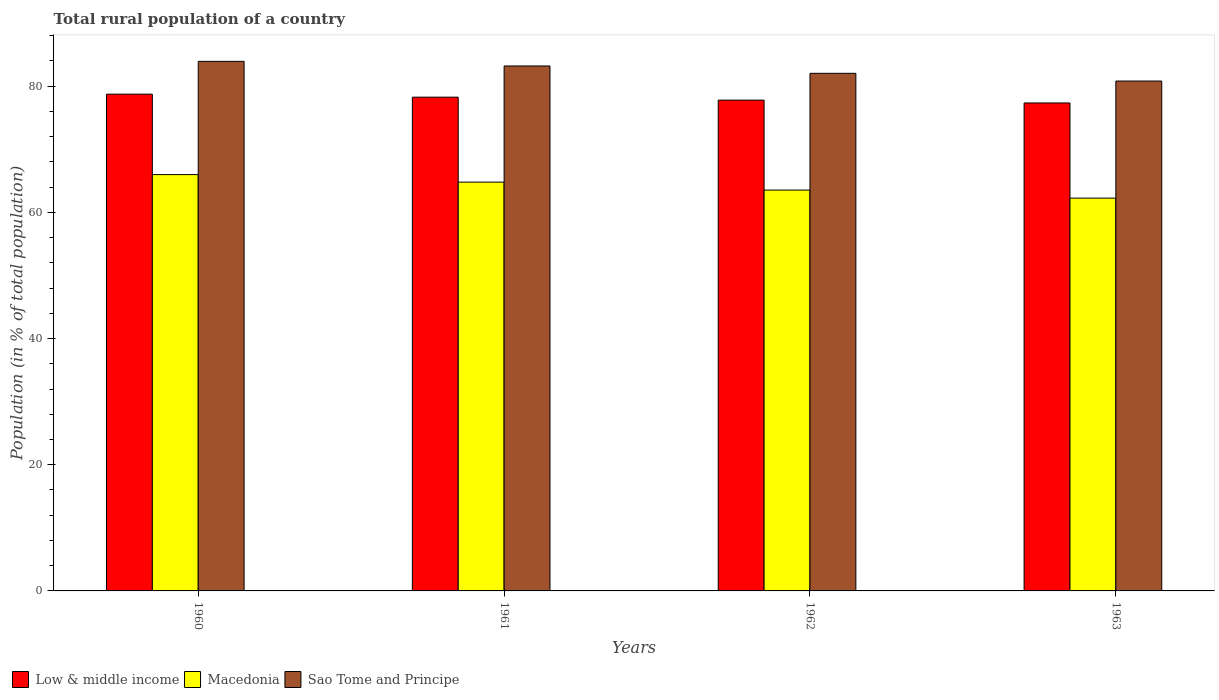How many bars are there on the 4th tick from the right?
Ensure brevity in your answer.  3. What is the label of the 1st group of bars from the left?
Keep it short and to the point. 1960. In how many cases, is the number of bars for a given year not equal to the number of legend labels?
Give a very brief answer. 0. What is the rural population in Low & middle income in 1960?
Your answer should be compact. 78.73. Across all years, what is the maximum rural population in Low & middle income?
Keep it short and to the point. 78.73. Across all years, what is the minimum rural population in Low & middle income?
Offer a very short reply. 77.33. In which year was the rural population in Macedonia minimum?
Your response must be concise. 1963. What is the total rural population in Macedonia in the graph?
Ensure brevity in your answer.  256.54. What is the difference between the rural population in Sao Tome and Principe in 1961 and that in 1963?
Offer a terse response. 2.39. What is the difference between the rural population in Macedonia in 1962 and the rural population in Sao Tome and Principe in 1960?
Your response must be concise. -20.4. What is the average rural population in Macedonia per year?
Keep it short and to the point. 64.14. In the year 1961, what is the difference between the rural population in Sao Tome and Principe and rural population in Low & middle income?
Your answer should be compact. 4.94. In how many years, is the rural population in Low & middle income greater than 52 %?
Your answer should be very brief. 4. What is the ratio of the rural population in Low & middle income in 1960 to that in 1961?
Offer a very short reply. 1.01. Is the rural population in Low & middle income in 1962 less than that in 1963?
Provide a succinct answer. No. What is the difference between the highest and the second highest rural population in Low & middle income?
Your answer should be very brief. 0.48. What is the difference between the highest and the lowest rural population in Macedonia?
Give a very brief answer. 3.73. Is the sum of the rural population in Low & middle income in 1960 and 1961 greater than the maximum rural population in Sao Tome and Principe across all years?
Make the answer very short. Yes. What does the 3rd bar from the left in 1961 represents?
Keep it short and to the point. Sao Tome and Principe. What does the 2nd bar from the right in 1960 represents?
Make the answer very short. Macedonia. How many bars are there?
Give a very brief answer. 12. Are all the bars in the graph horizontal?
Ensure brevity in your answer.  No. How many years are there in the graph?
Provide a succinct answer. 4. Are the values on the major ticks of Y-axis written in scientific E-notation?
Ensure brevity in your answer.  No. Does the graph contain any zero values?
Provide a short and direct response. No. Does the graph contain grids?
Keep it short and to the point. No. Where does the legend appear in the graph?
Your response must be concise. Bottom left. How many legend labels are there?
Your answer should be very brief. 3. What is the title of the graph?
Offer a very short reply. Total rural population of a country. What is the label or title of the X-axis?
Your answer should be compact. Years. What is the label or title of the Y-axis?
Give a very brief answer. Population (in % of total population). What is the Population (in % of total population) in Low & middle income in 1960?
Offer a very short reply. 78.73. What is the Population (in % of total population) in Macedonia in 1960?
Your answer should be very brief. 65.98. What is the Population (in % of total population) of Sao Tome and Principe in 1960?
Offer a very short reply. 83.93. What is the Population (in % of total population) of Low & middle income in 1961?
Make the answer very short. 78.25. What is the Population (in % of total population) in Macedonia in 1961?
Keep it short and to the point. 64.79. What is the Population (in % of total population) of Sao Tome and Principe in 1961?
Your response must be concise. 83.19. What is the Population (in % of total population) of Low & middle income in 1962?
Offer a very short reply. 77.78. What is the Population (in % of total population) of Macedonia in 1962?
Keep it short and to the point. 63.53. What is the Population (in % of total population) of Sao Tome and Principe in 1962?
Keep it short and to the point. 82.03. What is the Population (in % of total population) of Low & middle income in 1963?
Your answer should be compact. 77.33. What is the Population (in % of total population) in Macedonia in 1963?
Your answer should be compact. 62.25. What is the Population (in % of total population) in Sao Tome and Principe in 1963?
Offer a very short reply. 80.81. Across all years, what is the maximum Population (in % of total population) of Low & middle income?
Your answer should be very brief. 78.73. Across all years, what is the maximum Population (in % of total population) in Macedonia?
Your response must be concise. 65.98. Across all years, what is the maximum Population (in % of total population) of Sao Tome and Principe?
Ensure brevity in your answer.  83.93. Across all years, what is the minimum Population (in % of total population) in Low & middle income?
Your response must be concise. 77.33. Across all years, what is the minimum Population (in % of total population) in Macedonia?
Your answer should be compact. 62.25. Across all years, what is the minimum Population (in % of total population) of Sao Tome and Principe?
Offer a very short reply. 80.81. What is the total Population (in % of total population) in Low & middle income in the graph?
Your answer should be compact. 312.09. What is the total Population (in % of total population) in Macedonia in the graph?
Make the answer very short. 256.54. What is the total Population (in % of total population) in Sao Tome and Principe in the graph?
Give a very brief answer. 329.96. What is the difference between the Population (in % of total population) in Low & middle income in 1960 and that in 1961?
Your answer should be compact. 0.48. What is the difference between the Population (in % of total population) in Macedonia in 1960 and that in 1961?
Your answer should be very brief. 1.19. What is the difference between the Population (in % of total population) in Sao Tome and Principe in 1960 and that in 1961?
Keep it short and to the point. 0.73. What is the difference between the Population (in % of total population) in Low & middle income in 1960 and that in 1962?
Your answer should be compact. 0.95. What is the difference between the Population (in % of total population) of Macedonia in 1960 and that in 1962?
Your answer should be compact. 2.45. What is the difference between the Population (in % of total population) in Sao Tome and Principe in 1960 and that in 1962?
Keep it short and to the point. 1.9. What is the difference between the Population (in % of total population) in Low & middle income in 1960 and that in 1963?
Offer a terse response. 1.39. What is the difference between the Population (in % of total population) in Macedonia in 1960 and that in 1963?
Provide a short and direct response. 3.73. What is the difference between the Population (in % of total population) of Sao Tome and Principe in 1960 and that in 1963?
Offer a very short reply. 3.12. What is the difference between the Population (in % of total population) of Low & middle income in 1961 and that in 1962?
Provide a succinct answer. 0.47. What is the difference between the Population (in % of total population) in Macedonia in 1961 and that in 1962?
Your response must be concise. 1.26. What is the difference between the Population (in % of total population) of Sao Tome and Principe in 1961 and that in 1962?
Give a very brief answer. 1.16. What is the difference between the Population (in % of total population) of Low & middle income in 1961 and that in 1963?
Provide a succinct answer. 0.92. What is the difference between the Population (in % of total population) of Macedonia in 1961 and that in 1963?
Give a very brief answer. 2.54. What is the difference between the Population (in % of total population) of Sao Tome and Principe in 1961 and that in 1963?
Your answer should be compact. 2.39. What is the difference between the Population (in % of total population) in Low & middle income in 1962 and that in 1963?
Your answer should be compact. 0.45. What is the difference between the Population (in % of total population) of Macedonia in 1962 and that in 1963?
Your answer should be compact. 1.28. What is the difference between the Population (in % of total population) in Sao Tome and Principe in 1962 and that in 1963?
Ensure brevity in your answer.  1.23. What is the difference between the Population (in % of total population) in Low & middle income in 1960 and the Population (in % of total population) in Macedonia in 1961?
Ensure brevity in your answer.  13.94. What is the difference between the Population (in % of total population) in Low & middle income in 1960 and the Population (in % of total population) in Sao Tome and Principe in 1961?
Ensure brevity in your answer.  -4.47. What is the difference between the Population (in % of total population) of Macedonia in 1960 and the Population (in % of total population) of Sao Tome and Principe in 1961?
Your response must be concise. -17.21. What is the difference between the Population (in % of total population) of Low & middle income in 1960 and the Population (in % of total population) of Macedonia in 1962?
Your answer should be compact. 15.2. What is the difference between the Population (in % of total population) in Low & middle income in 1960 and the Population (in % of total population) in Sao Tome and Principe in 1962?
Your answer should be compact. -3.3. What is the difference between the Population (in % of total population) in Macedonia in 1960 and the Population (in % of total population) in Sao Tome and Principe in 1962?
Your answer should be compact. -16.05. What is the difference between the Population (in % of total population) of Low & middle income in 1960 and the Population (in % of total population) of Macedonia in 1963?
Your response must be concise. 16.48. What is the difference between the Population (in % of total population) in Low & middle income in 1960 and the Population (in % of total population) in Sao Tome and Principe in 1963?
Provide a succinct answer. -2.08. What is the difference between the Population (in % of total population) in Macedonia in 1960 and the Population (in % of total population) in Sao Tome and Principe in 1963?
Provide a succinct answer. -14.83. What is the difference between the Population (in % of total population) of Low & middle income in 1961 and the Population (in % of total population) of Macedonia in 1962?
Offer a very short reply. 14.72. What is the difference between the Population (in % of total population) in Low & middle income in 1961 and the Population (in % of total population) in Sao Tome and Principe in 1962?
Offer a terse response. -3.78. What is the difference between the Population (in % of total population) of Macedonia in 1961 and the Population (in % of total population) of Sao Tome and Principe in 1962?
Offer a very short reply. -17.25. What is the difference between the Population (in % of total population) of Low & middle income in 1961 and the Population (in % of total population) of Macedonia in 1963?
Provide a succinct answer. 16. What is the difference between the Population (in % of total population) in Low & middle income in 1961 and the Population (in % of total population) in Sao Tome and Principe in 1963?
Provide a succinct answer. -2.56. What is the difference between the Population (in % of total population) of Macedonia in 1961 and the Population (in % of total population) of Sao Tome and Principe in 1963?
Your answer should be compact. -16.02. What is the difference between the Population (in % of total population) of Low & middle income in 1962 and the Population (in % of total population) of Macedonia in 1963?
Your response must be concise. 15.53. What is the difference between the Population (in % of total population) of Low & middle income in 1962 and the Population (in % of total population) of Sao Tome and Principe in 1963?
Offer a very short reply. -3.02. What is the difference between the Population (in % of total population) of Macedonia in 1962 and the Population (in % of total population) of Sao Tome and Principe in 1963?
Provide a short and direct response. -17.28. What is the average Population (in % of total population) of Low & middle income per year?
Provide a succinct answer. 78.02. What is the average Population (in % of total population) in Macedonia per year?
Ensure brevity in your answer.  64.14. What is the average Population (in % of total population) of Sao Tome and Principe per year?
Make the answer very short. 82.49. In the year 1960, what is the difference between the Population (in % of total population) in Low & middle income and Population (in % of total population) in Macedonia?
Your response must be concise. 12.75. In the year 1960, what is the difference between the Population (in % of total population) of Low & middle income and Population (in % of total population) of Sao Tome and Principe?
Make the answer very short. -5.2. In the year 1960, what is the difference between the Population (in % of total population) of Macedonia and Population (in % of total population) of Sao Tome and Principe?
Keep it short and to the point. -17.95. In the year 1961, what is the difference between the Population (in % of total population) of Low & middle income and Population (in % of total population) of Macedonia?
Your answer should be compact. 13.46. In the year 1961, what is the difference between the Population (in % of total population) of Low & middle income and Population (in % of total population) of Sao Tome and Principe?
Keep it short and to the point. -4.94. In the year 1961, what is the difference between the Population (in % of total population) in Macedonia and Population (in % of total population) in Sao Tome and Principe?
Offer a very short reply. -18.41. In the year 1962, what is the difference between the Population (in % of total population) in Low & middle income and Population (in % of total population) in Macedonia?
Your answer should be very brief. 14.26. In the year 1962, what is the difference between the Population (in % of total population) of Low & middle income and Population (in % of total population) of Sao Tome and Principe?
Make the answer very short. -4.25. In the year 1962, what is the difference between the Population (in % of total population) in Macedonia and Population (in % of total population) in Sao Tome and Principe?
Your response must be concise. -18.5. In the year 1963, what is the difference between the Population (in % of total population) in Low & middle income and Population (in % of total population) in Macedonia?
Your answer should be very brief. 15.08. In the year 1963, what is the difference between the Population (in % of total population) of Low & middle income and Population (in % of total population) of Sao Tome and Principe?
Keep it short and to the point. -3.47. In the year 1963, what is the difference between the Population (in % of total population) of Macedonia and Population (in % of total population) of Sao Tome and Principe?
Your answer should be very brief. -18.56. What is the ratio of the Population (in % of total population) of Low & middle income in 1960 to that in 1961?
Your answer should be compact. 1.01. What is the ratio of the Population (in % of total population) in Macedonia in 1960 to that in 1961?
Make the answer very short. 1.02. What is the ratio of the Population (in % of total population) in Sao Tome and Principe in 1960 to that in 1961?
Make the answer very short. 1.01. What is the ratio of the Population (in % of total population) in Low & middle income in 1960 to that in 1962?
Ensure brevity in your answer.  1.01. What is the ratio of the Population (in % of total population) in Macedonia in 1960 to that in 1962?
Your answer should be very brief. 1.04. What is the ratio of the Population (in % of total population) of Sao Tome and Principe in 1960 to that in 1962?
Provide a succinct answer. 1.02. What is the ratio of the Population (in % of total population) of Low & middle income in 1960 to that in 1963?
Your answer should be very brief. 1.02. What is the ratio of the Population (in % of total population) of Macedonia in 1960 to that in 1963?
Keep it short and to the point. 1.06. What is the ratio of the Population (in % of total population) in Sao Tome and Principe in 1960 to that in 1963?
Your answer should be very brief. 1.04. What is the ratio of the Population (in % of total population) in Low & middle income in 1961 to that in 1962?
Your answer should be compact. 1.01. What is the ratio of the Population (in % of total population) of Macedonia in 1961 to that in 1962?
Keep it short and to the point. 1.02. What is the ratio of the Population (in % of total population) of Sao Tome and Principe in 1961 to that in 1962?
Offer a terse response. 1.01. What is the ratio of the Population (in % of total population) of Low & middle income in 1961 to that in 1963?
Provide a short and direct response. 1.01. What is the ratio of the Population (in % of total population) of Macedonia in 1961 to that in 1963?
Give a very brief answer. 1.04. What is the ratio of the Population (in % of total population) in Sao Tome and Principe in 1961 to that in 1963?
Make the answer very short. 1.03. What is the ratio of the Population (in % of total population) in Low & middle income in 1962 to that in 1963?
Provide a short and direct response. 1.01. What is the ratio of the Population (in % of total population) of Macedonia in 1962 to that in 1963?
Ensure brevity in your answer.  1.02. What is the ratio of the Population (in % of total population) of Sao Tome and Principe in 1962 to that in 1963?
Give a very brief answer. 1.02. What is the difference between the highest and the second highest Population (in % of total population) of Low & middle income?
Ensure brevity in your answer.  0.48. What is the difference between the highest and the second highest Population (in % of total population) in Macedonia?
Offer a very short reply. 1.19. What is the difference between the highest and the second highest Population (in % of total population) of Sao Tome and Principe?
Your response must be concise. 0.73. What is the difference between the highest and the lowest Population (in % of total population) in Low & middle income?
Ensure brevity in your answer.  1.39. What is the difference between the highest and the lowest Population (in % of total population) of Macedonia?
Provide a succinct answer. 3.73. What is the difference between the highest and the lowest Population (in % of total population) in Sao Tome and Principe?
Make the answer very short. 3.12. 